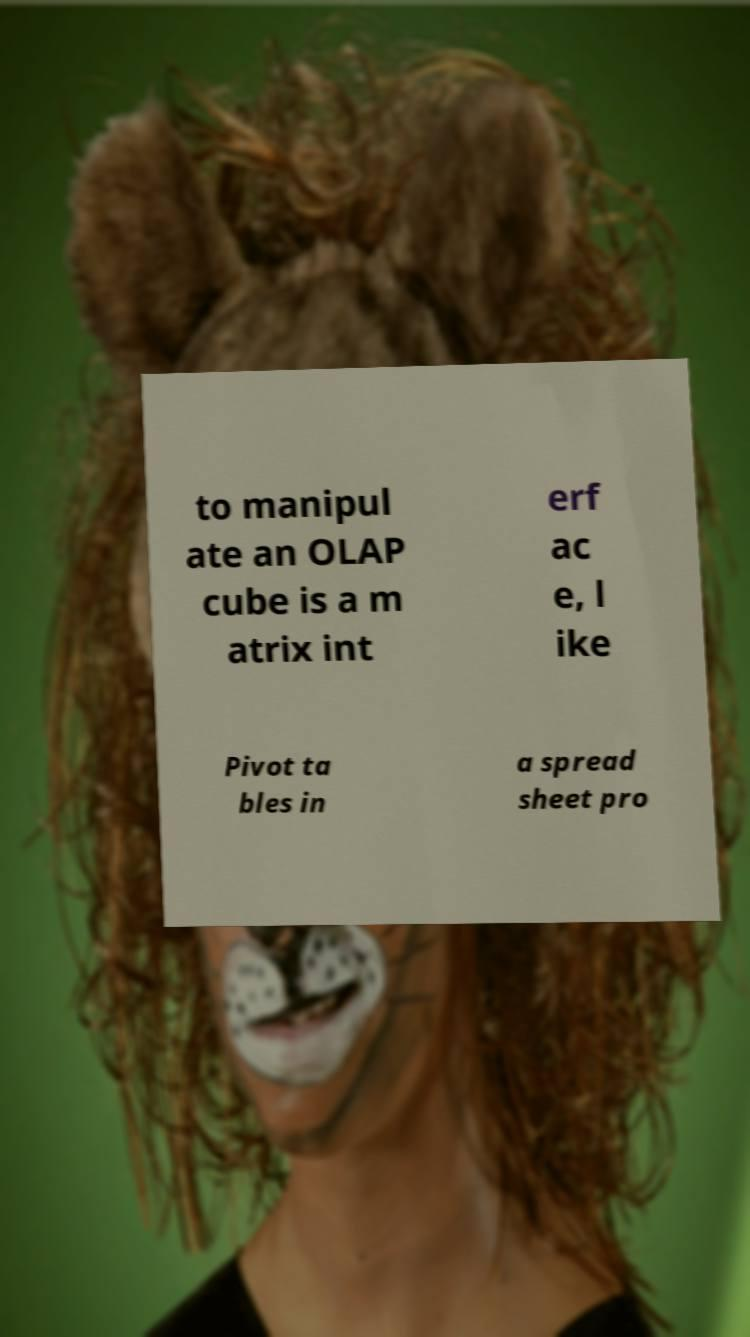What messages or text are displayed in this image? I need them in a readable, typed format. to manipul ate an OLAP cube is a m atrix int erf ac e, l ike Pivot ta bles in a spread sheet pro 